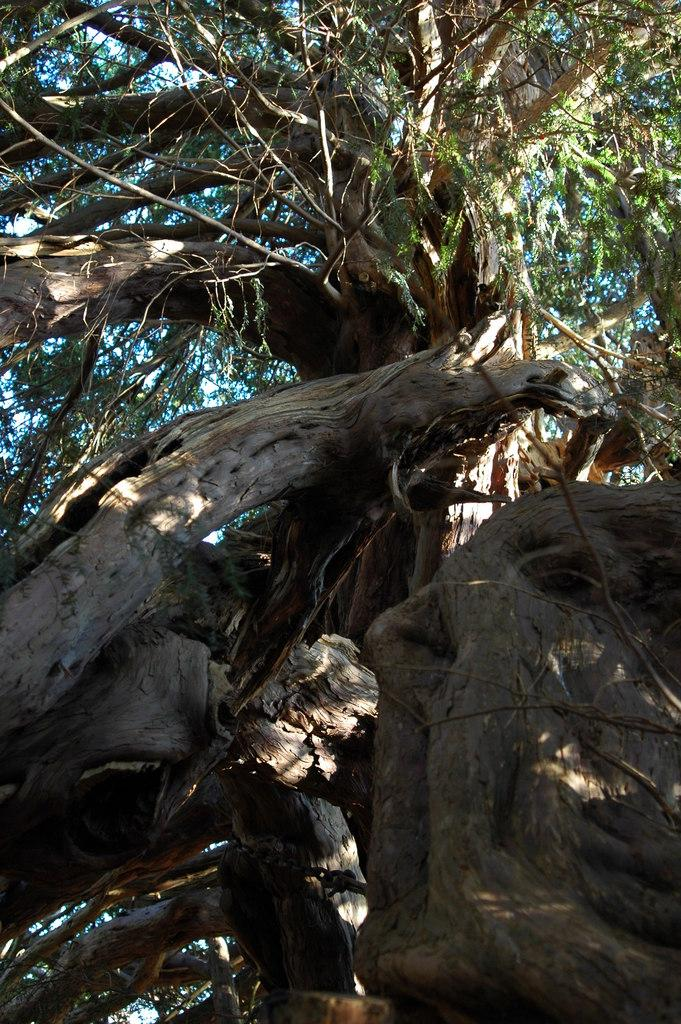What type of vegetation is present in the image? There are branches of a tree in the image. What can be seen in the background of the image? The sky is visible in the background of the image. What is the relation between the branches and the competition in the image? There is no competition present in the image, so there is no relation between the branches and a competition. 